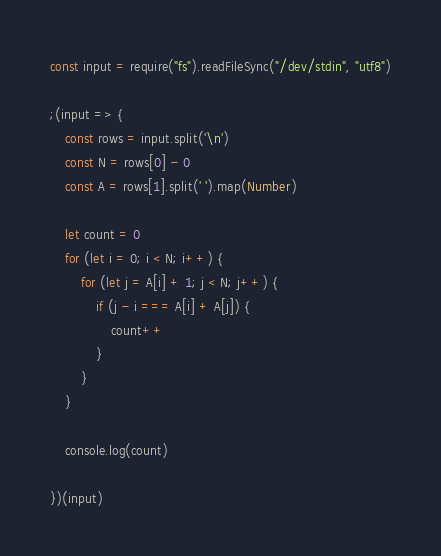<code> <loc_0><loc_0><loc_500><loc_500><_JavaScript_>const input = require("fs").readFileSync("/dev/stdin", "utf8")

;(input => {
    const rows = input.split('\n')
    const N = rows[0] - 0
    const A = rows[1].split(' ').map(Number)

    let count = 0
    for (let i = 0; i < N; i++) {
        for (let j = A[i] + 1; j < N; j++) {
            if (j - i === A[i] + A[j]) {
                count++
            }
        }
    }

    console.log(count)

})(input)
</code> 